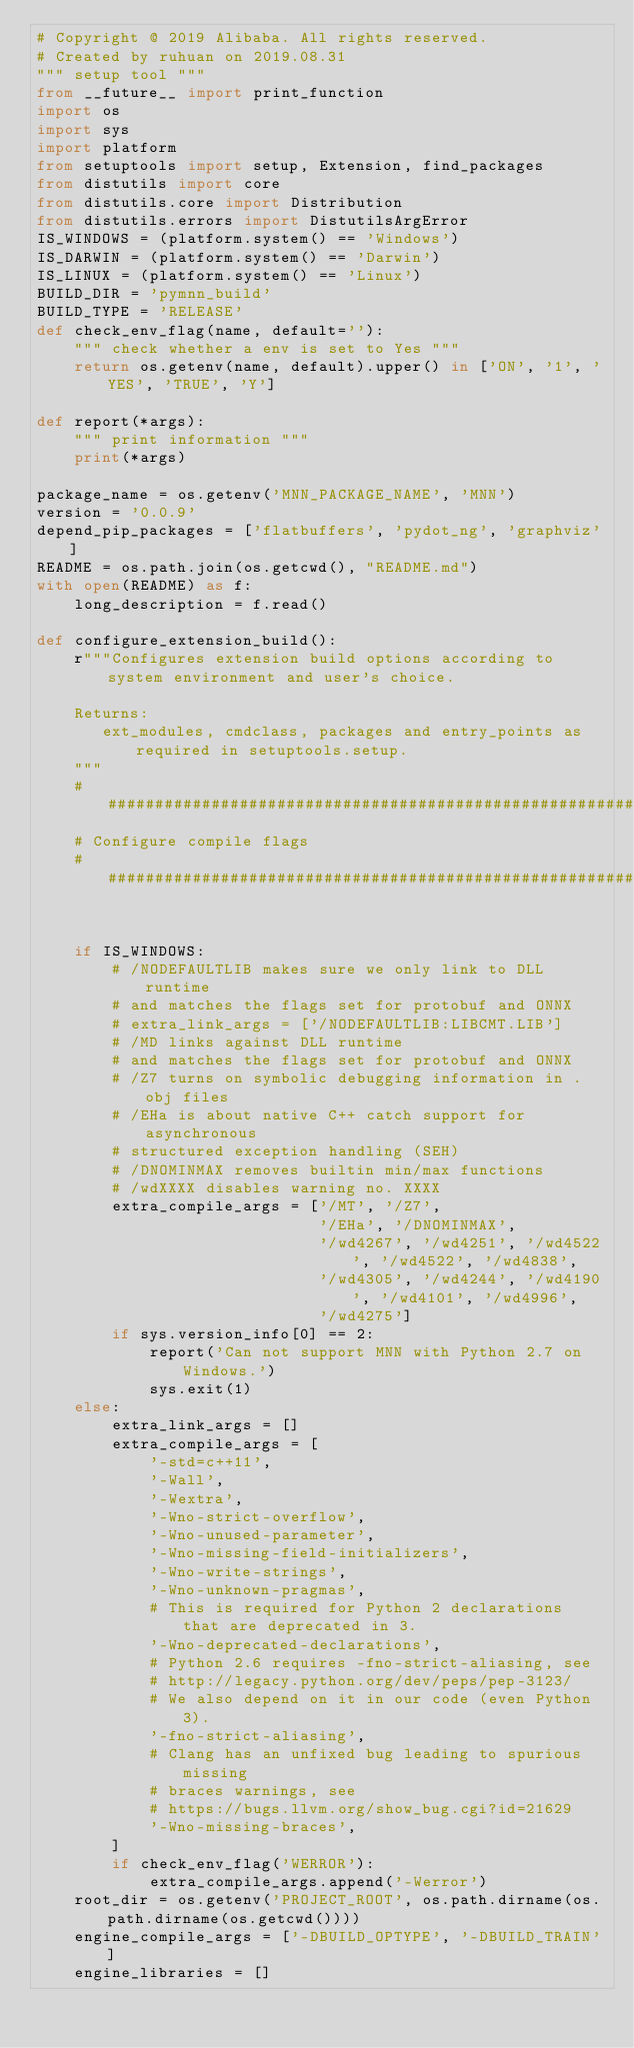<code> <loc_0><loc_0><loc_500><loc_500><_Python_># Copyright @ 2019 Alibaba. All rights reserved.
# Created by ruhuan on 2019.08.31
""" setup tool """
from __future__ import print_function
import os
import sys
import platform
from setuptools import setup, Extension, find_packages
from distutils import core
from distutils.core import Distribution
from distutils.errors import DistutilsArgError
IS_WINDOWS = (platform.system() == 'Windows')
IS_DARWIN = (platform.system() == 'Darwin')
IS_LINUX = (platform.system() == 'Linux')
BUILD_DIR = 'pymnn_build'
BUILD_TYPE = 'RELEASE'
def check_env_flag(name, default=''):
    """ check whether a env is set to Yes """
    return os.getenv(name, default).upper() in ['ON', '1', 'YES', 'TRUE', 'Y']

def report(*args):
    """ print information """
    print(*args)

package_name = os.getenv('MNN_PACKAGE_NAME', 'MNN')
version = '0.0.9'
depend_pip_packages = ['flatbuffers', 'pydot_ng', 'graphviz']
README = os.path.join(os.getcwd(), "README.md")
with open(README) as f:
    long_description = f.read()

def configure_extension_build():
    r"""Configures extension build options according to system environment and user's choice.

    Returns:
       ext_modules, cmdclass, packages and entry_points as required in setuptools.setup.
    """
    ################################################################################
    # Configure compile flags
    ################################################################################


    if IS_WINDOWS:
        # /NODEFAULTLIB makes sure we only link to DLL runtime
        # and matches the flags set for protobuf and ONNX
        # extra_link_args = ['/NODEFAULTLIB:LIBCMT.LIB']
        # /MD links against DLL runtime
        # and matches the flags set for protobuf and ONNX
        # /Z7 turns on symbolic debugging information in .obj files
        # /EHa is about native C++ catch support for asynchronous
        # structured exception handling (SEH)
        # /DNOMINMAX removes builtin min/max functions
        # /wdXXXX disables warning no. XXXX
        extra_compile_args = ['/MT', '/Z7',
                              '/EHa', '/DNOMINMAX',
                              '/wd4267', '/wd4251', '/wd4522', '/wd4522', '/wd4838',
                              '/wd4305', '/wd4244', '/wd4190', '/wd4101', '/wd4996',
                              '/wd4275']
        if sys.version_info[0] == 2:
            report('Can not support MNN with Python 2.7 on Windows.')
            sys.exit(1)
    else:
        extra_link_args = []
        extra_compile_args = [
            '-std=c++11',
            '-Wall',
            '-Wextra',
            '-Wno-strict-overflow',
            '-Wno-unused-parameter',
            '-Wno-missing-field-initializers',
            '-Wno-write-strings',
            '-Wno-unknown-pragmas',
            # This is required for Python 2 declarations that are deprecated in 3.
            '-Wno-deprecated-declarations',
            # Python 2.6 requires -fno-strict-aliasing, see
            # http://legacy.python.org/dev/peps/pep-3123/
            # We also depend on it in our code (even Python 3).
            '-fno-strict-aliasing',
            # Clang has an unfixed bug leading to spurious missing
            # braces warnings, see
            # https://bugs.llvm.org/show_bug.cgi?id=21629
            '-Wno-missing-braces',
        ]
        if check_env_flag('WERROR'):
            extra_compile_args.append('-Werror')
    root_dir = os.getenv('PROJECT_ROOT', os.path.dirname(os.path.dirname(os.getcwd())))
    engine_compile_args = ['-DBUILD_OPTYPE', '-DBUILD_TRAIN']
    engine_libraries = []</code> 